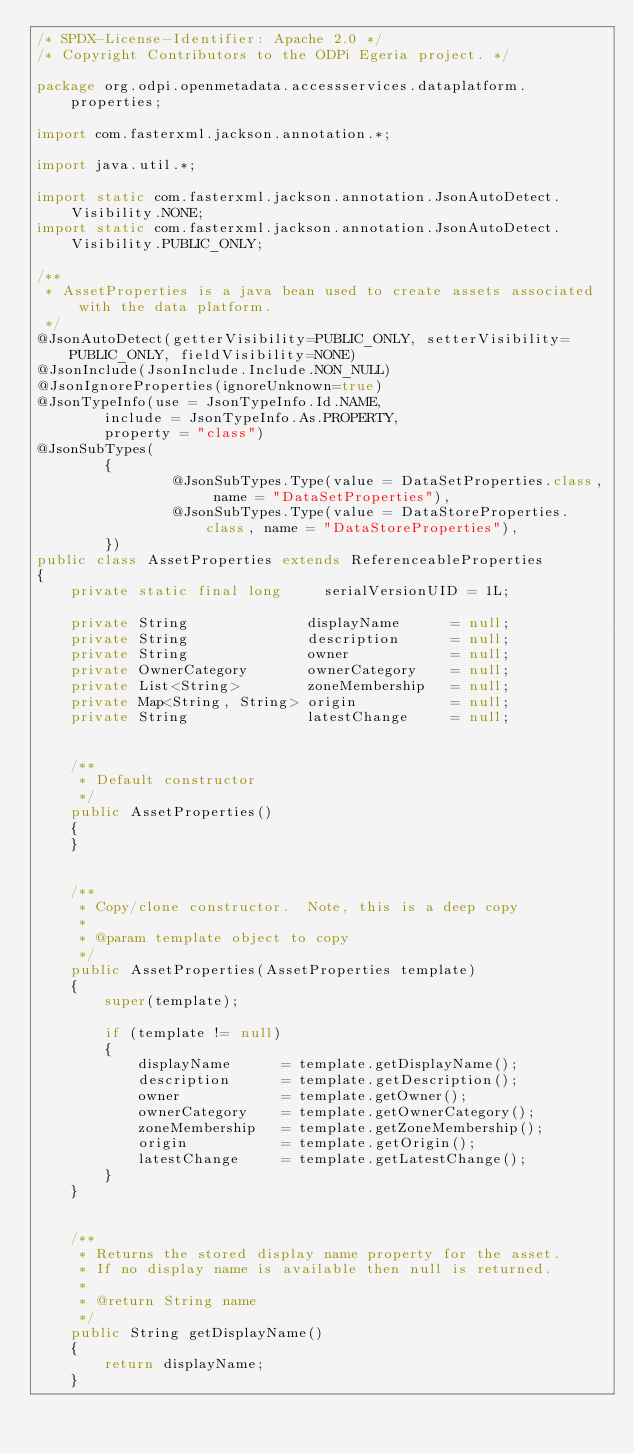<code> <loc_0><loc_0><loc_500><loc_500><_Java_>/* SPDX-License-Identifier: Apache 2.0 */
/* Copyright Contributors to the ODPi Egeria project. */

package org.odpi.openmetadata.accessservices.dataplatform.properties;

import com.fasterxml.jackson.annotation.*;

import java.util.*;

import static com.fasterxml.jackson.annotation.JsonAutoDetect.Visibility.NONE;
import static com.fasterxml.jackson.annotation.JsonAutoDetect.Visibility.PUBLIC_ONLY;

/**
 * AssetProperties is a java bean used to create assets associated with the data platform.
 */
@JsonAutoDetect(getterVisibility=PUBLIC_ONLY, setterVisibility=PUBLIC_ONLY, fieldVisibility=NONE)
@JsonInclude(JsonInclude.Include.NON_NULL)
@JsonIgnoreProperties(ignoreUnknown=true)
@JsonTypeInfo(use = JsonTypeInfo.Id.NAME,
        include = JsonTypeInfo.As.PROPERTY,
        property = "class")
@JsonSubTypes(
        {
                @JsonSubTypes.Type(value = DataSetProperties.class, name = "DataSetProperties"),
                @JsonSubTypes.Type(value = DataStoreProperties.class, name = "DataStoreProperties"),
        })
public class AssetProperties extends ReferenceableProperties
{
    private static final long     serialVersionUID = 1L;

    private String              displayName      = null;
    private String              description      = null;
    private String              owner            = null;
    private OwnerCategory       ownerCategory    = null;
    private List<String>        zoneMembership   = null;
    private Map<String, String> origin           = null;
    private String              latestChange     = null;


    /**
     * Default constructor
     */
    public AssetProperties()
    {
    }


    /**
     * Copy/clone constructor.  Note, this is a deep copy
     *
     * @param template object to copy
     */
    public AssetProperties(AssetProperties template)
    {
        super(template);

        if (template != null)
        {
            displayName      = template.getDisplayName();
            description      = template.getDescription();
            owner            = template.getOwner();
            ownerCategory    = template.getOwnerCategory();
            zoneMembership   = template.getZoneMembership();
            origin           = template.getOrigin();
            latestChange     = template.getLatestChange();
        }
    }


    /**
     * Returns the stored display name property for the asset.
     * If no display name is available then null is returned.
     *
     * @return String name
     */
    public String getDisplayName()
    {
        return displayName;
    }

</code> 